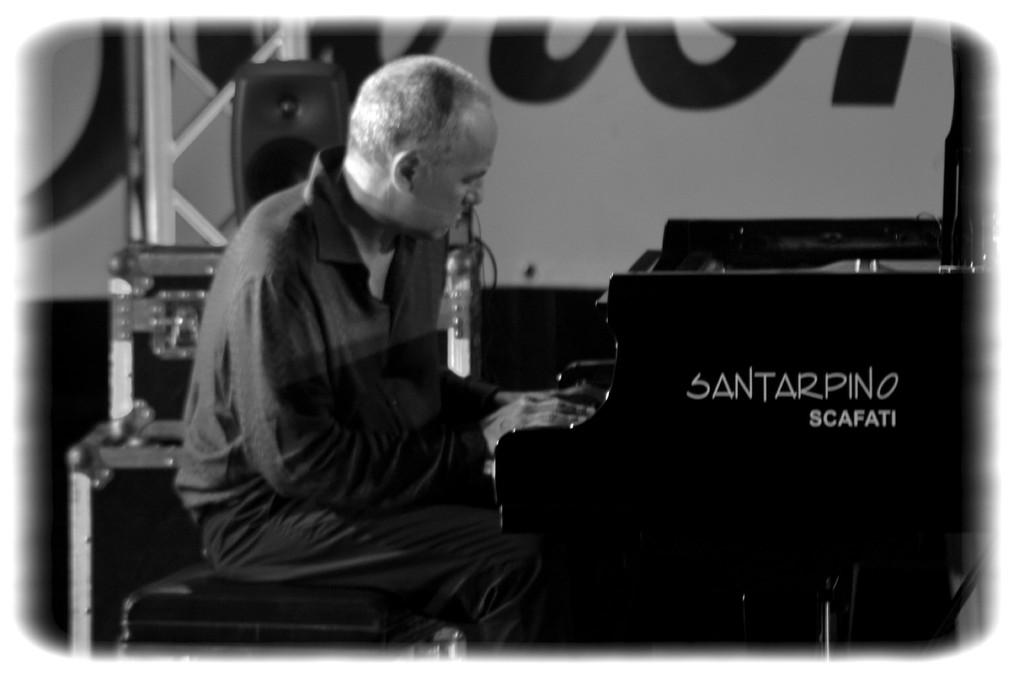Who is the main subject in the image? There is a man in the image. What is the man doing in the image? The man is playing the piano. What is the man sitting on while playing the piano? The man is sitting on a stool. Where is the piano located in relation to the man? The piano is in front of the man. Is the piano stuck in quicksand in the image? No, the piano is not stuck in quicksand in the image; it is on a stable surface in front of the man. What role does the actor play in the image? There is no actor mentioned in the image, only a man playing the piano. 